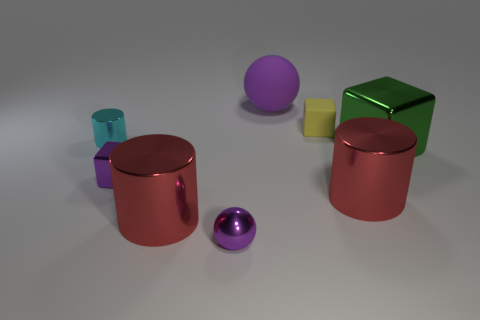Add 1 blocks. How many objects exist? 9 Subtract all blocks. How many objects are left? 5 Add 5 metal balls. How many metal balls are left? 6 Add 7 green objects. How many green objects exist? 8 Subtract 1 cyan cylinders. How many objects are left? 7 Subtract all large green objects. Subtract all large green metallic blocks. How many objects are left? 6 